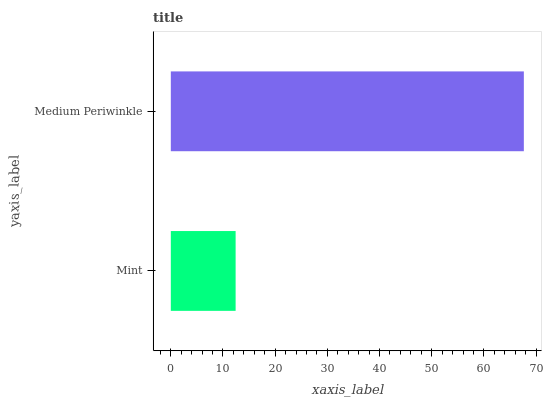Is Mint the minimum?
Answer yes or no. Yes. Is Medium Periwinkle the maximum?
Answer yes or no. Yes. Is Medium Periwinkle the minimum?
Answer yes or no. No. Is Medium Periwinkle greater than Mint?
Answer yes or no. Yes. Is Mint less than Medium Periwinkle?
Answer yes or no. Yes. Is Mint greater than Medium Periwinkle?
Answer yes or no. No. Is Medium Periwinkle less than Mint?
Answer yes or no. No. Is Medium Periwinkle the high median?
Answer yes or no. Yes. Is Mint the low median?
Answer yes or no. Yes. Is Mint the high median?
Answer yes or no. No. Is Medium Periwinkle the low median?
Answer yes or no. No. 